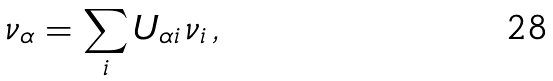<formula> <loc_0><loc_0><loc_500><loc_500>\nu _ { \alpha } = \sum _ { i } U _ { \alpha i } \, \nu _ { i } \, ,</formula> 